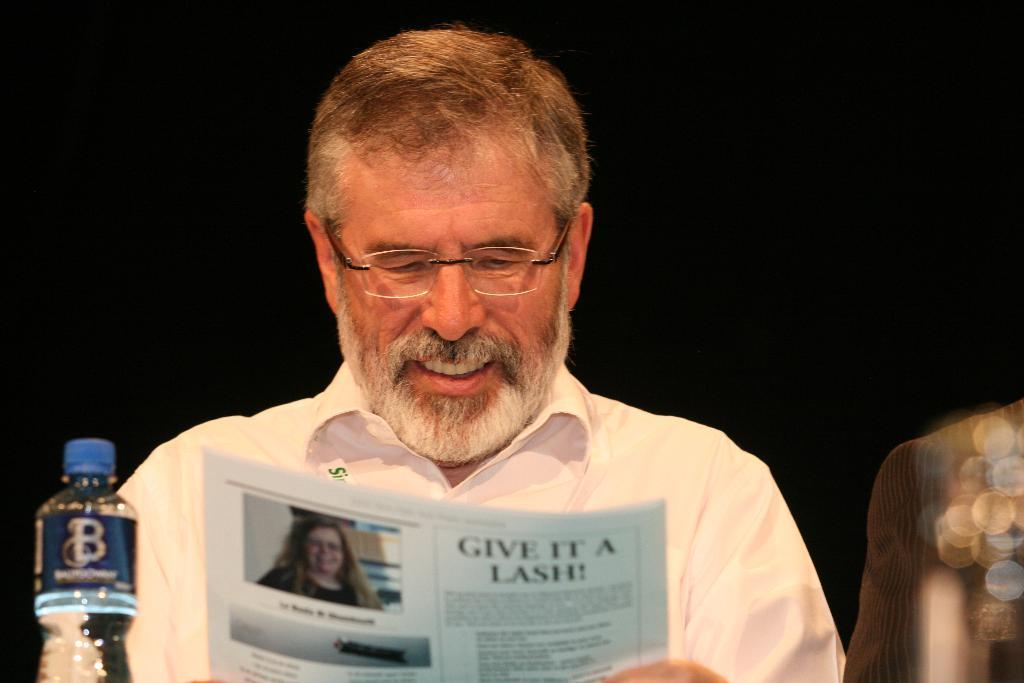Who or what is the main subject in the image? There is a person in the image. What is the person wearing? The person is wearing a white shirt. What is the person holding in his hand? The person is holding a paper in his hand. What can be seen in front of the person? There is a water bottle in front of the person. What type of veil is covering the person's nose in the image? There is no veil or any object covering the person's nose in the image. What time of day is it in the image, based on the hour? The provided facts do not mention the time of day or any specific hour, so it cannot be determined from the image. 